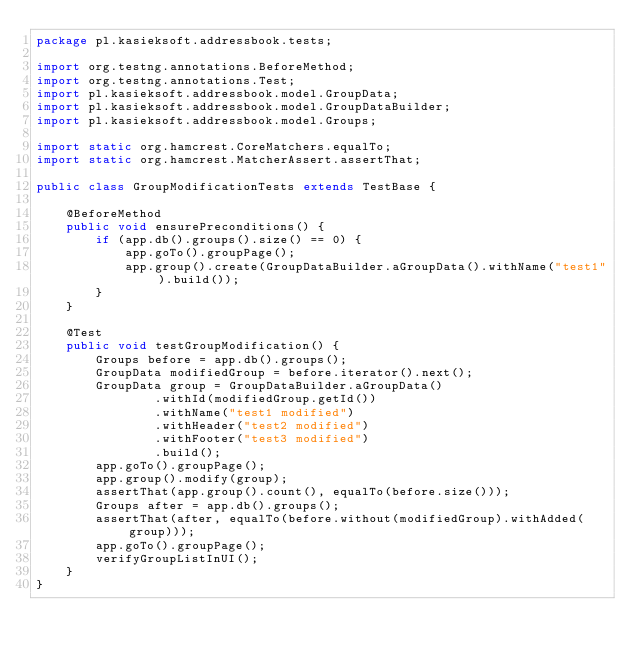Convert code to text. <code><loc_0><loc_0><loc_500><loc_500><_Java_>package pl.kasieksoft.addressbook.tests;

import org.testng.annotations.BeforeMethod;
import org.testng.annotations.Test;
import pl.kasieksoft.addressbook.model.GroupData;
import pl.kasieksoft.addressbook.model.GroupDataBuilder;
import pl.kasieksoft.addressbook.model.Groups;

import static org.hamcrest.CoreMatchers.equalTo;
import static org.hamcrest.MatcherAssert.assertThat;

public class GroupModificationTests extends TestBase {

    @BeforeMethod
    public void ensurePreconditions() {
        if (app.db().groups().size() == 0) {
            app.goTo().groupPage();
            app.group().create(GroupDataBuilder.aGroupData().withName("test1").build());
        }
    }

    @Test
    public void testGroupModification() {
        Groups before = app.db().groups();
        GroupData modifiedGroup = before.iterator().next();
        GroupData group = GroupDataBuilder.aGroupData()
                .withId(modifiedGroup.getId())
                .withName("test1 modified")
                .withHeader("test2 modified")
                .withFooter("test3 modified")
                .build();
        app.goTo().groupPage();
        app.group().modify(group);
        assertThat(app.group().count(), equalTo(before.size()));
        Groups after = app.db().groups();
        assertThat(after, equalTo(before.without(modifiedGroup).withAdded(group)));
        app.goTo().groupPage();
        verifyGroupListInUI();
    }
}
</code> 